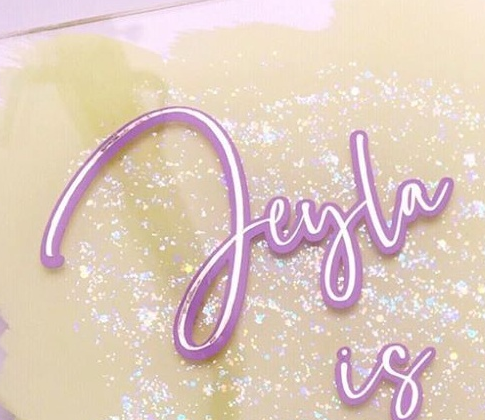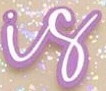Read the text from these images in sequence, separated by a semicolon. Jeyla; is 